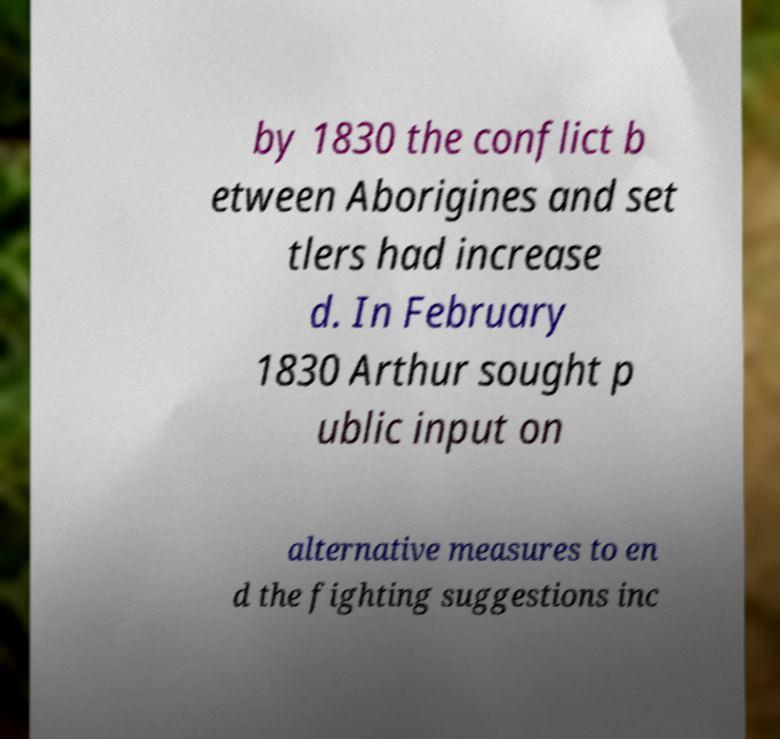Could you extract and type out the text from this image? by 1830 the conflict b etween Aborigines and set tlers had increase d. In February 1830 Arthur sought p ublic input on alternative measures to en d the fighting suggestions inc 